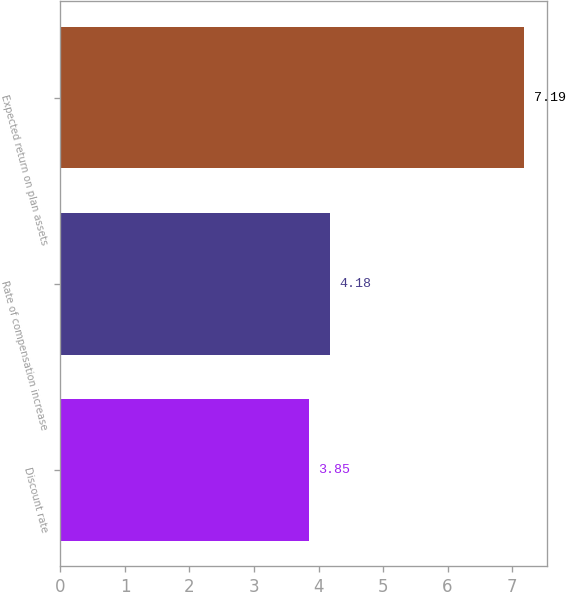<chart> <loc_0><loc_0><loc_500><loc_500><bar_chart><fcel>Discount rate<fcel>Rate of compensation increase<fcel>Expected return on plan assets<nl><fcel>3.85<fcel>4.18<fcel>7.19<nl></chart> 